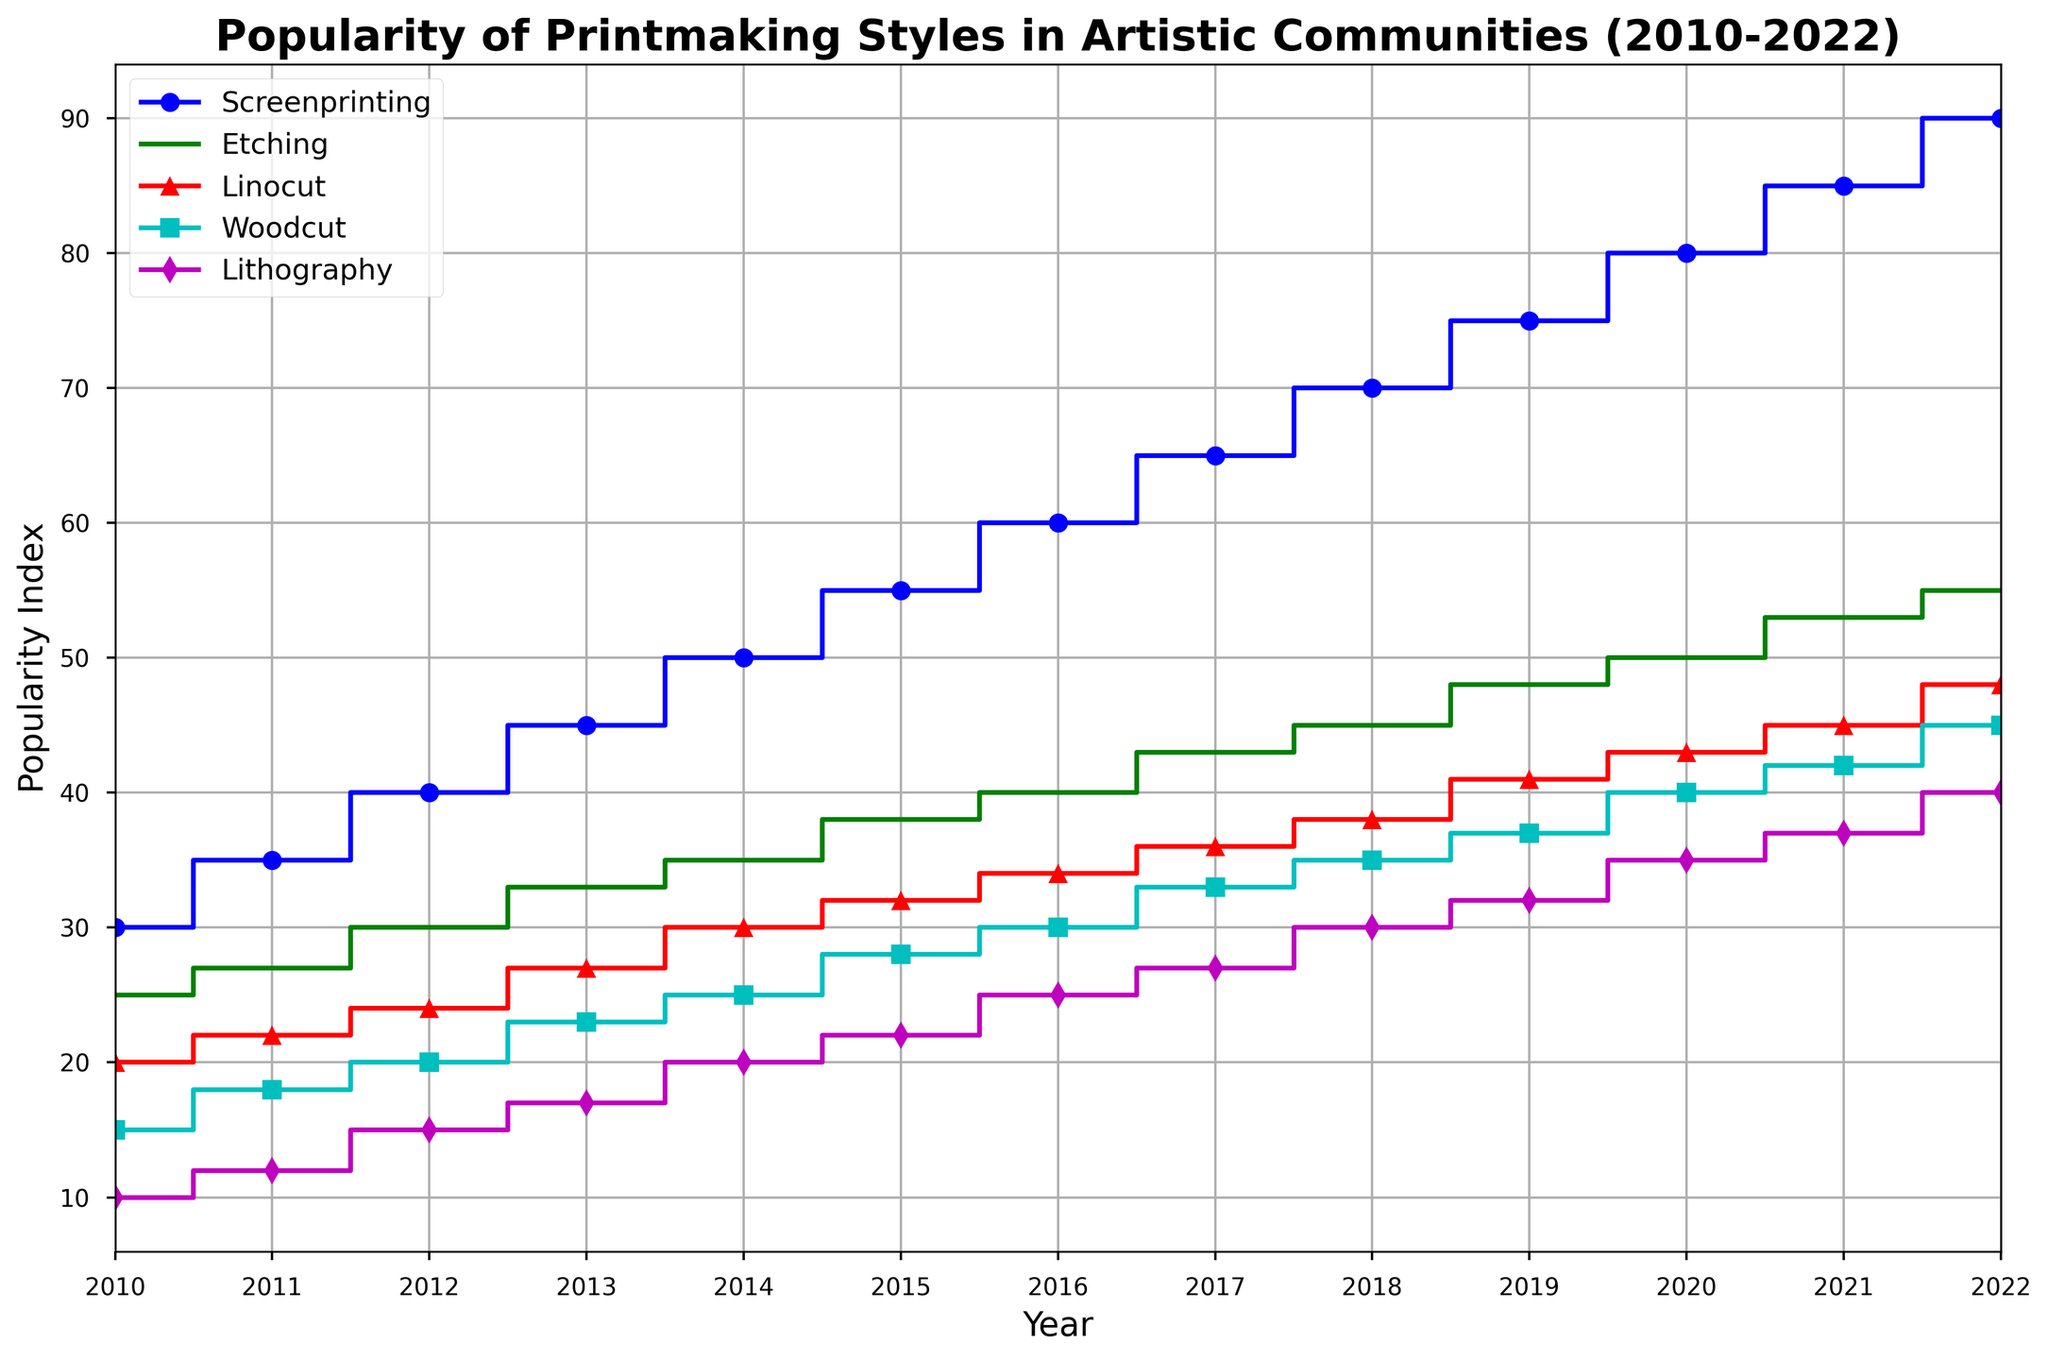Which printmaking style shows the highest popularity increase from 2010 to 2022? Screenprinting increases from 30 in 2010 to 90 in 2022. Etching increases from 25 to 55. Linocut increases from 20 to 48. Woodcut increases from 15 to 45. Lithography increases from 10 to 40. Screenprinting has the highest increase.
Answer: Screenprinting Which year did Lithography surpass a popularity index of 30? Observe that Lithography reaches a popularity index of 30 in 2018.
Answer: 2018 How does the popularity of Linocut in 2014 compare to Etching in 2012? The popularity of Linocut in 2014 is 30, while the popularity of Etching in 2012 is 30. Hence, they have equal popularity in these years.
Answer: Equal Which printmaking style had the lowest popularity index in 2013? By observing the line plot, in 2013, Lithography has the lowest popularity index of 17.
Answer: Lithography Calculate the average popularity index of Screenprinting from 2010 to 2022. Add the popularity indices of Screenprinting from 2010 to 2022 and divide by the number of years: (30+35+40+45+50+55+60+65+70+75+80+85+90)/13 = 60
Answer: 60 Compare the increase in popularity for Etching and Lithography from 2010 to 2022. Which one saw a greater increase? Etching: 55 - 25 = 30. Lithography: 40 - 10 = 30. Both saw an equal increase of 30.
Answer: Equal What year did Screenprinting reach a popularity index of 80? Screenprinting reaches a popularity index of 80 in 2020.
Answer: 2020 Which two printmaking styles have the closest popularity indices in 2020 and what are they? In 2020, Linocut has a popularity of 43 and Woodcut has a popularity of 40. These two are the closest.
Answer: Linocut and Woodcut 